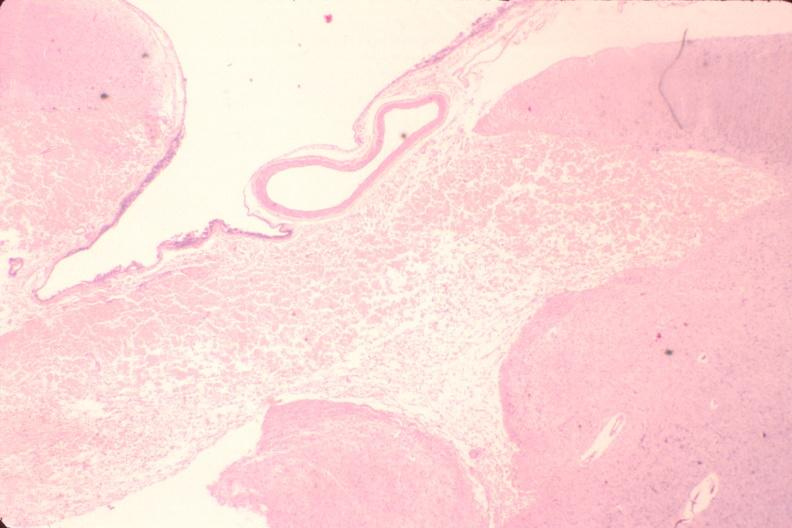s nervous present?
Answer the question using a single word or phrase. Yes 